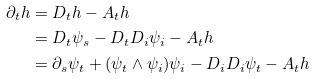<formula> <loc_0><loc_0><loc_500><loc_500>\partial _ { t } h & = D _ { t } h - A _ { t } h \\ & = D _ { t } \psi _ { s } - D _ { t } D _ { i } \psi _ { i } - A _ { t } h \\ & = \partial _ { s } \psi _ { t } + ( \psi _ { t } \wedge \psi _ { i } ) \psi _ { i } - D _ { i } D _ { i } \psi _ { t } - A _ { t } h</formula> 